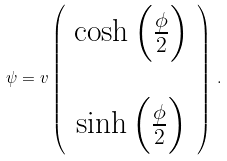<formula> <loc_0><loc_0><loc_500><loc_500>\psi = v \left ( \begin{array} { c } \cosh \left ( \frac { \phi } { 2 } \right ) \\ \\ \sinh \left ( \frac { \phi } { 2 } \right ) \end{array} \right ) \, .</formula> 